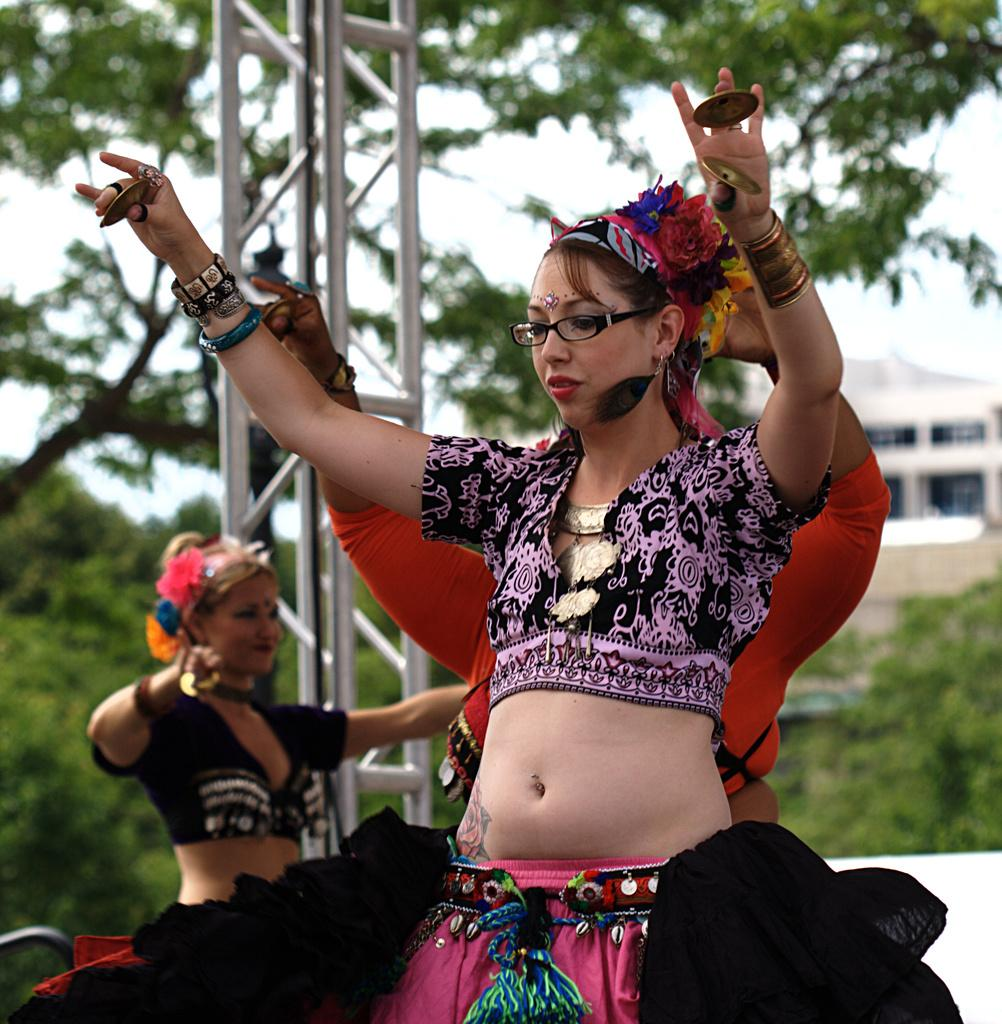How many people are in the image? There are people in the image, but the exact number is not specified. What can be seen in the background of the image? There is an object, trees, a building, and the sky visible in the background of the image. Can you describe the object in the background? Unfortunately, the facts provided do not give any details about the object in the background. How many cows are present in the image? There are no cows present in the image. What type of stove is being used by the team in the image? There is no stove or team present in the image. 